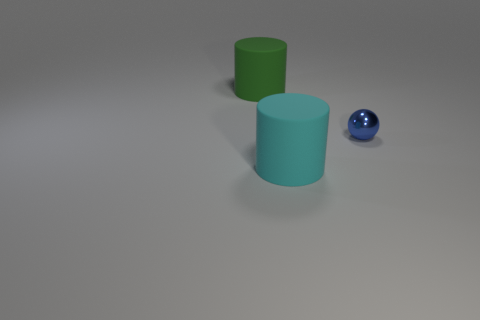What number of things are the same color as the small ball?
Offer a very short reply. 0. There is a ball; is its color the same as the large matte thing that is on the right side of the large green cylinder?
Keep it short and to the point. No. Are there more big cyan rubber cylinders than large balls?
Make the answer very short. Yes. What size is the other object that is the same shape as the cyan rubber object?
Your answer should be very brief. Large. Does the blue sphere have the same material as the big cylinder that is on the left side of the cyan rubber thing?
Offer a terse response. No. What number of things are big red metal balls or large cyan matte cylinders?
Offer a very short reply. 1. There is a cylinder behind the large cyan matte thing; is it the same size as the cylinder that is in front of the green cylinder?
Offer a terse response. Yes. How many cylinders are either blue things or green things?
Keep it short and to the point. 1. Are any small blue rubber blocks visible?
Give a very brief answer. No. Is there any other thing that is the same shape as the tiny object?
Your answer should be very brief. No. 